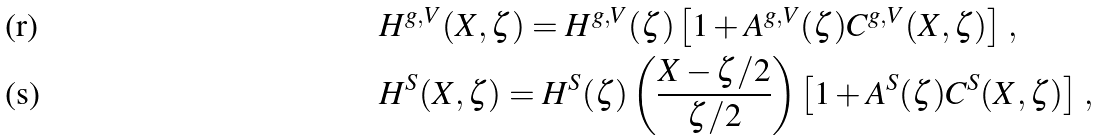Convert formula to latex. <formula><loc_0><loc_0><loc_500><loc_500>& H ^ { g , V } ( X , \zeta ) = H ^ { g , V } ( \zeta ) \left [ 1 + A ^ { g , V } ( \zeta ) C ^ { g , V } ( X , \zeta ) \right ] \, , \\ & H ^ { S } ( X , \zeta ) = H ^ { S } ( \zeta ) \left ( \frac { X - \zeta / 2 } { \zeta / 2 } \right ) \left [ 1 + A ^ { S } ( \zeta ) C ^ { S } ( X , \zeta ) \right ] \, ,</formula> 